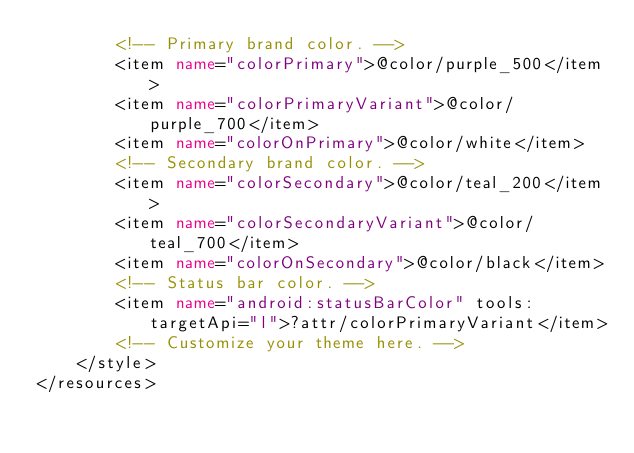Convert code to text. <code><loc_0><loc_0><loc_500><loc_500><_XML_>        <!-- Primary brand color. -->
        <item name="colorPrimary">@color/purple_500</item>
        <item name="colorPrimaryVariant">@color/purple_700</item>
        <item name="colorOnPrimary">@color/white</item>
        <!-- Secondary brand color. -->
        <item name="colorSecondary">@color/teal_200</item>
        <item name="colorSecondaryVariant">@color/teal_700</item>
        <item name="colorOnSecondary">@color/black</item>
        <!-- Status bar color. -->
        <item name="android:statusBarColor" tools:targetApi="l">?attr/colorPrimaryVariant</item>
        <!-- Customize your theme here. -->
    </style>
</resources></code> 